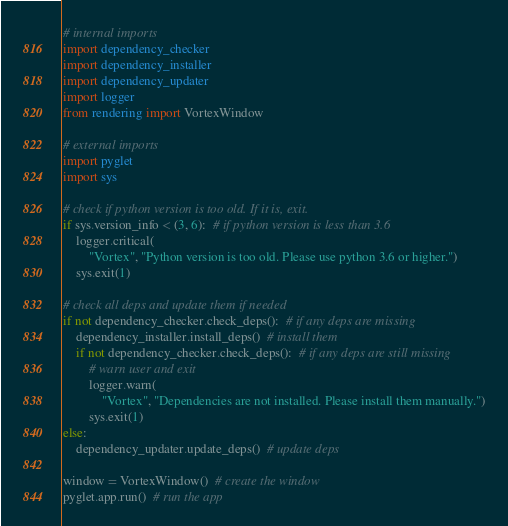Convert code to text. <code><loc_0><loc_0><loc_500><loc_500><_Python_># internal imports
import dependency_checker
import dependency_installer
import dependency_updater
import logger
from rendering import VortexWindow

# external imports
import pyglet
import sys

# check if python version is too old. If it is, exit.
if sys.version_info < (3, 6):  # if python version is less than 3.6
    logger.critical(
        "Vortex", "Python version is too old. Please use python 3.6 or higher.")
    sys.exit(1)

# check all deps and update them if needed
if not dependency_checker.check_deps():  # if any deps are missing
    dependency_installer.install_deps()  # install them
    if not dependency_checker.check_deps():  # if any deps are still missing
        # warn user and exit
        logger.warn(
            "Vortex", "Dependencies are not installed. Please install them manually.")
        sys.exit(1)
else:
    dependency_updater.update_deps()  # update deps

window = VortexWindow()  # create the window
pyglet.app.run()  # run the app
</code> 